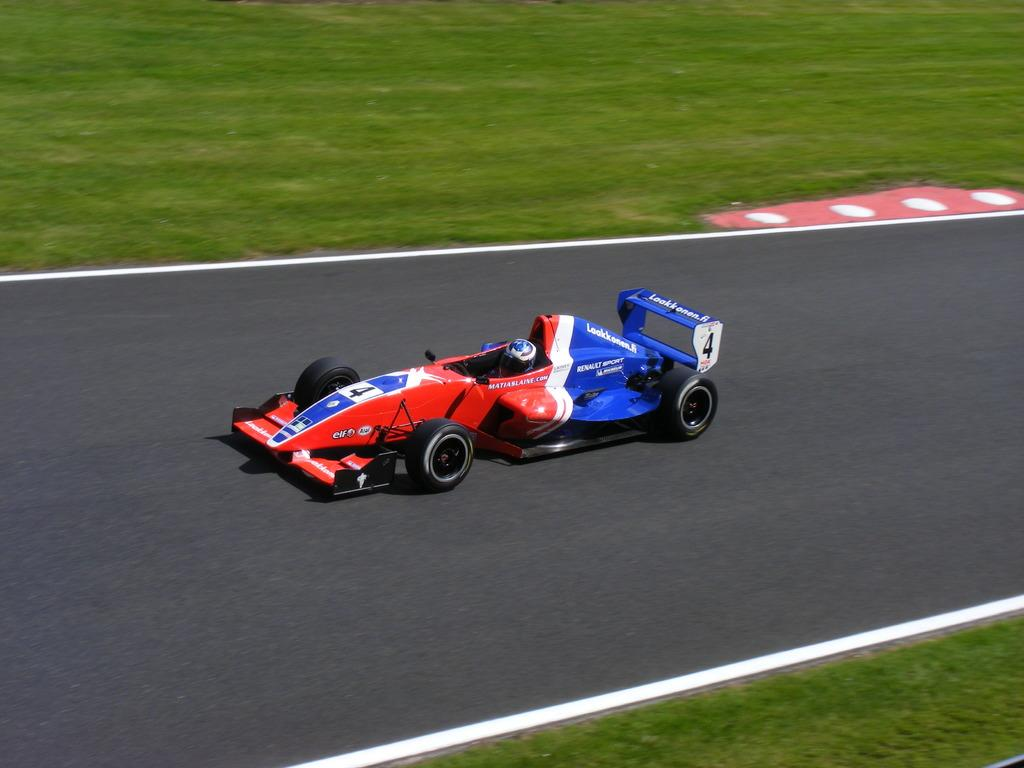What is the main subject of the image? The main subject of the image is a racing car. Where is the racing car located? The racing car is on the road. What can be seen on both sides of the road in the image? There is a grass garden on both sides of the road. How much money does the racing car cost in the image? There is no information about the price or cost of the racing car in the image. 